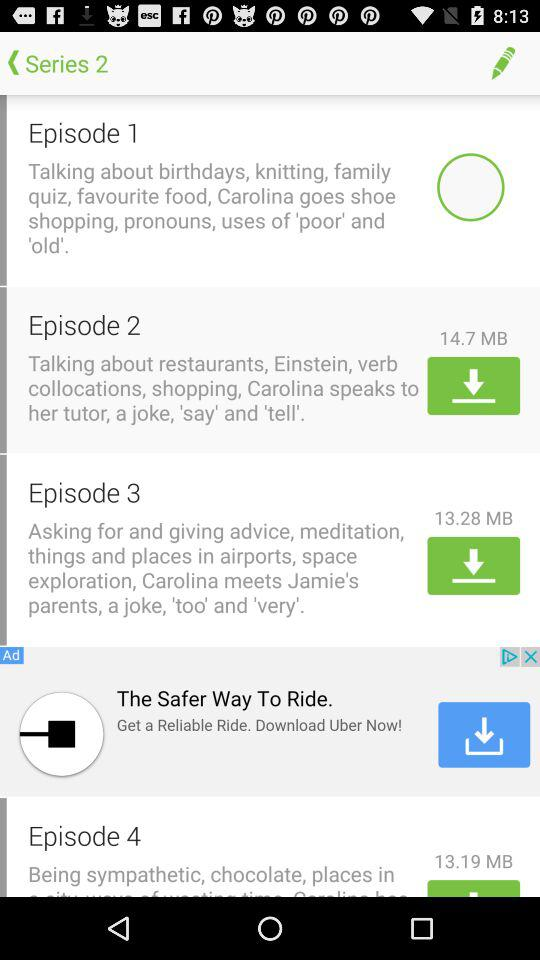What is the size of the "Episode 2" download file? The size is 14.7 MB. 